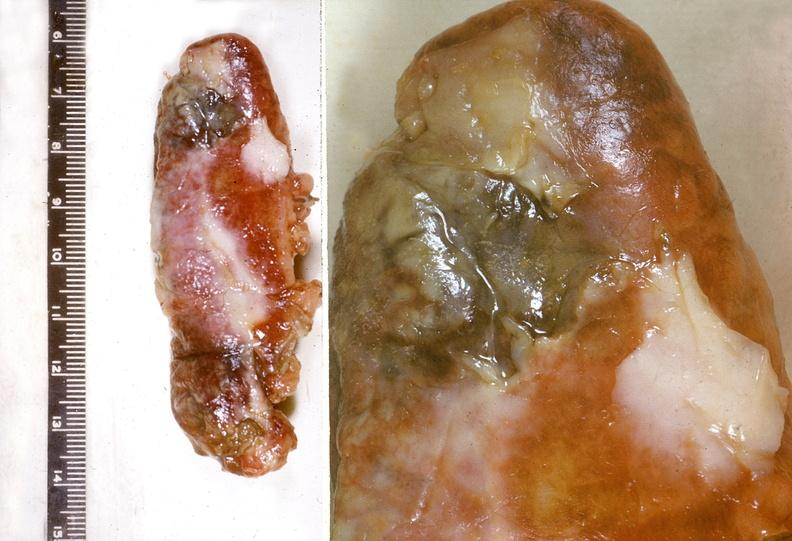s lymphangiomatosis generalized present?
Answer the question using a single word or phrase. No 